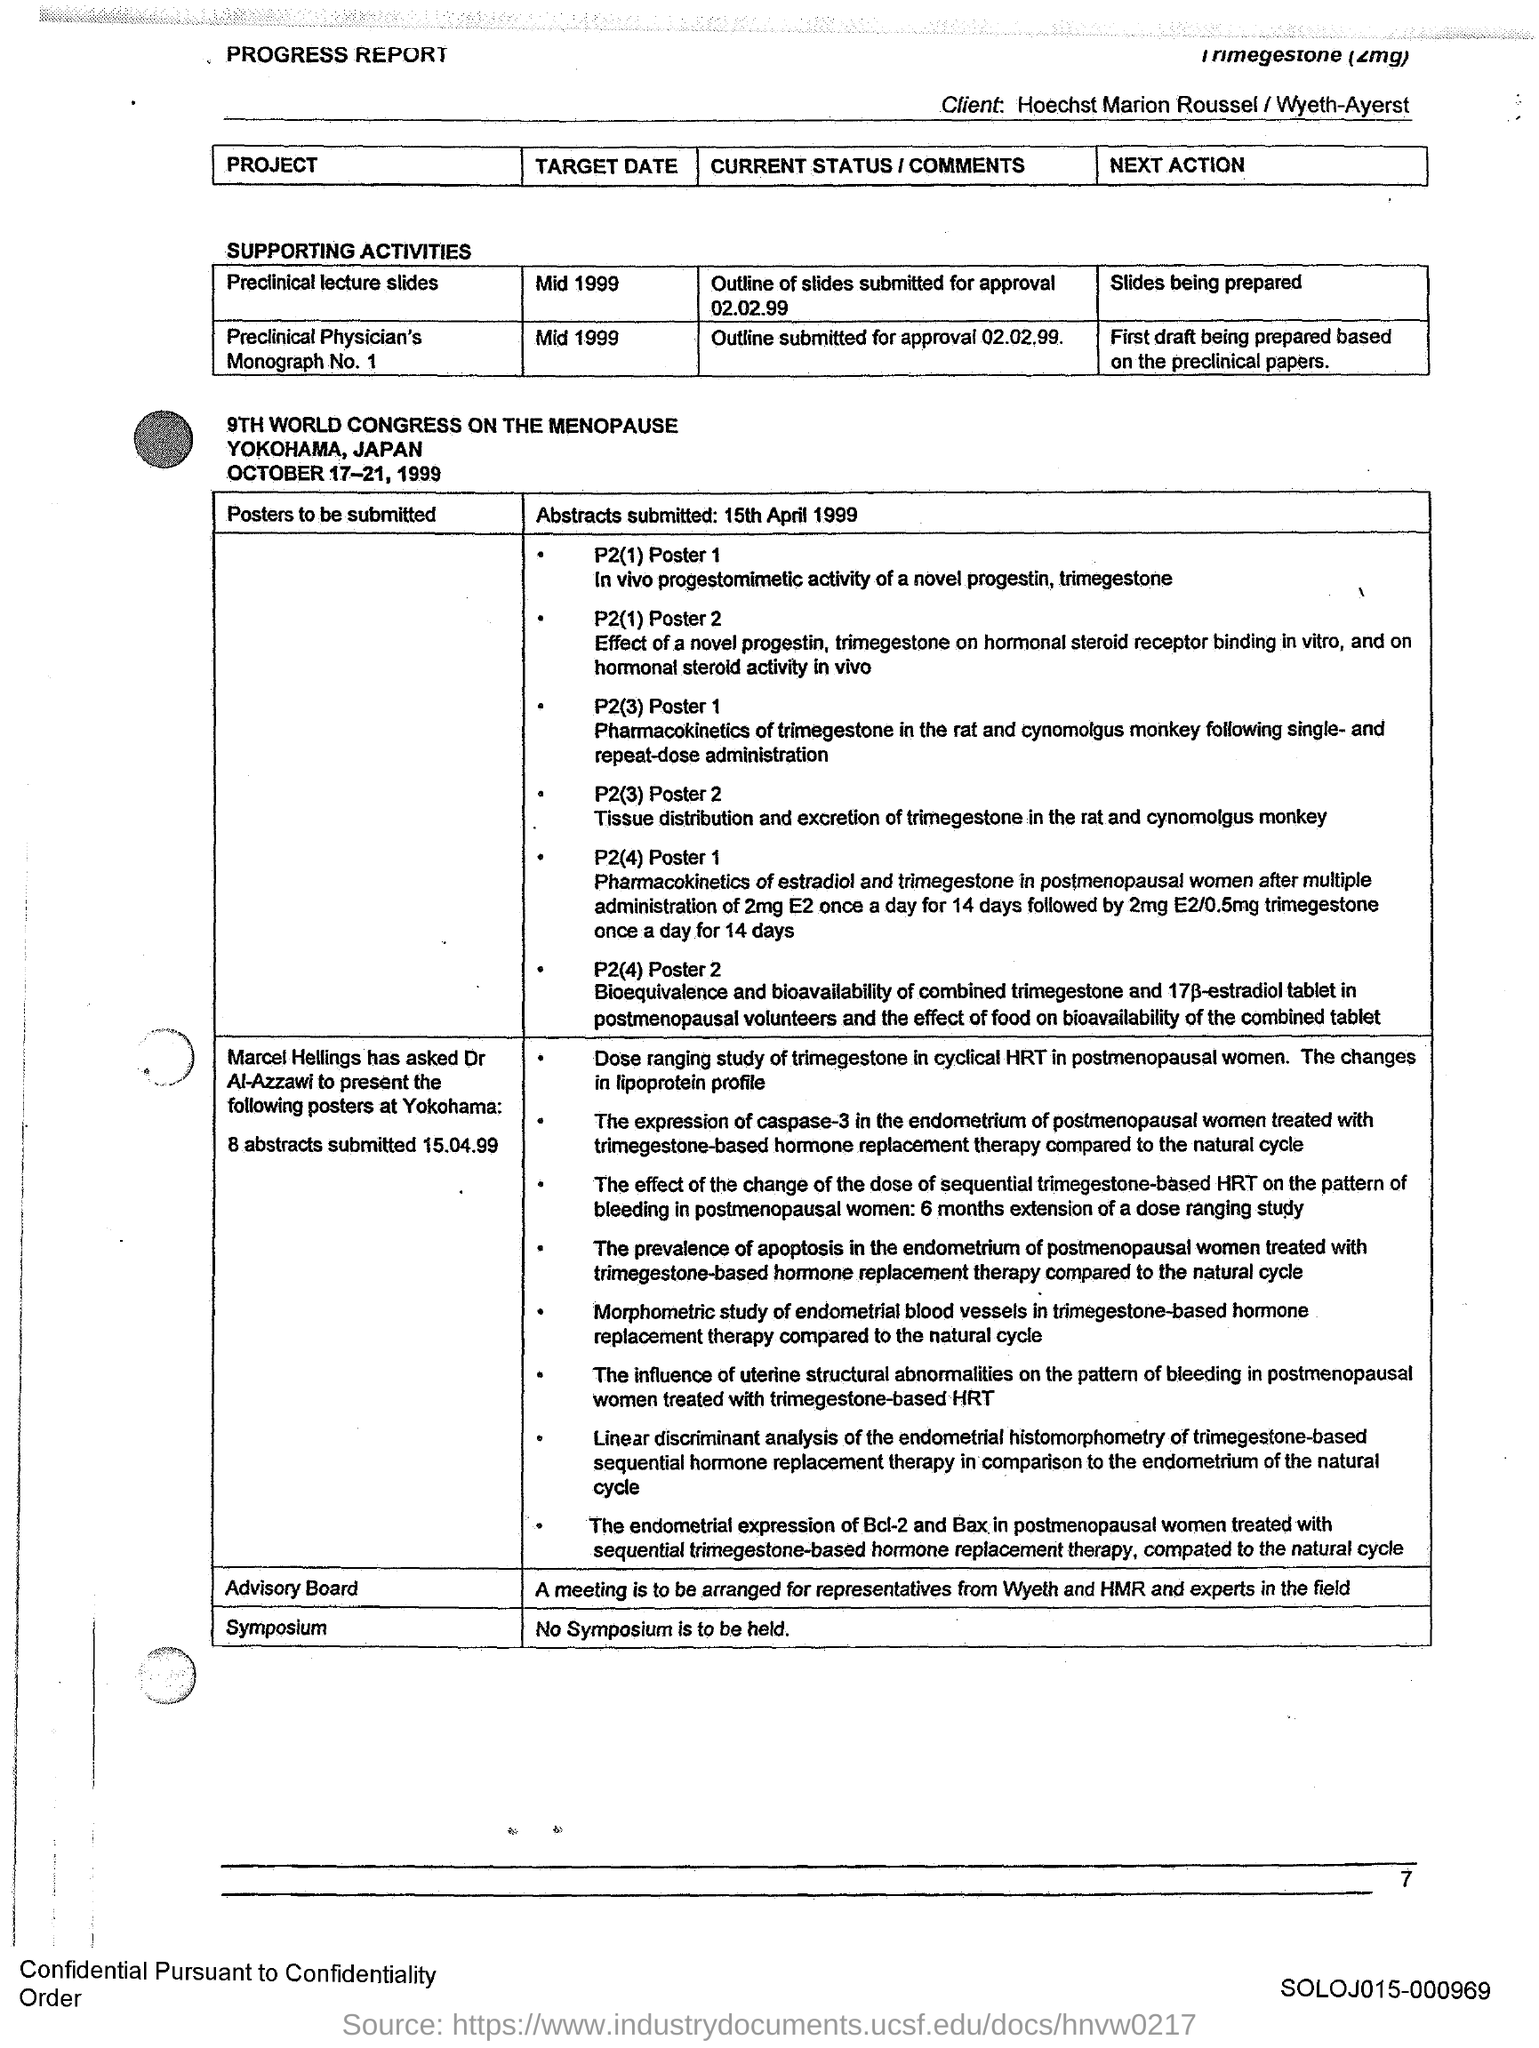Specify some key components in this picture. The target date for the "Preclinical Physician's Monograph No. 1" project is mid 1999. The target date for the "Preclinical Lecture Slides" project is mid-1999. 